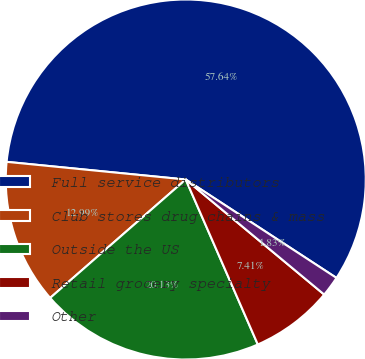<chart> <loc_0><loc_0><loc_500><loc_500><pie_chart><fcel>Full service distributors<fcel>Club stores drug chains & mass<fcel>Outside the US<fcel>Retail grocery specialty<fcel>Other<nl><fcel>57.64%<fcel>12.99%<fcel>20.13%<fcel>7.41%<fcel>1.83%<nl></chart> 